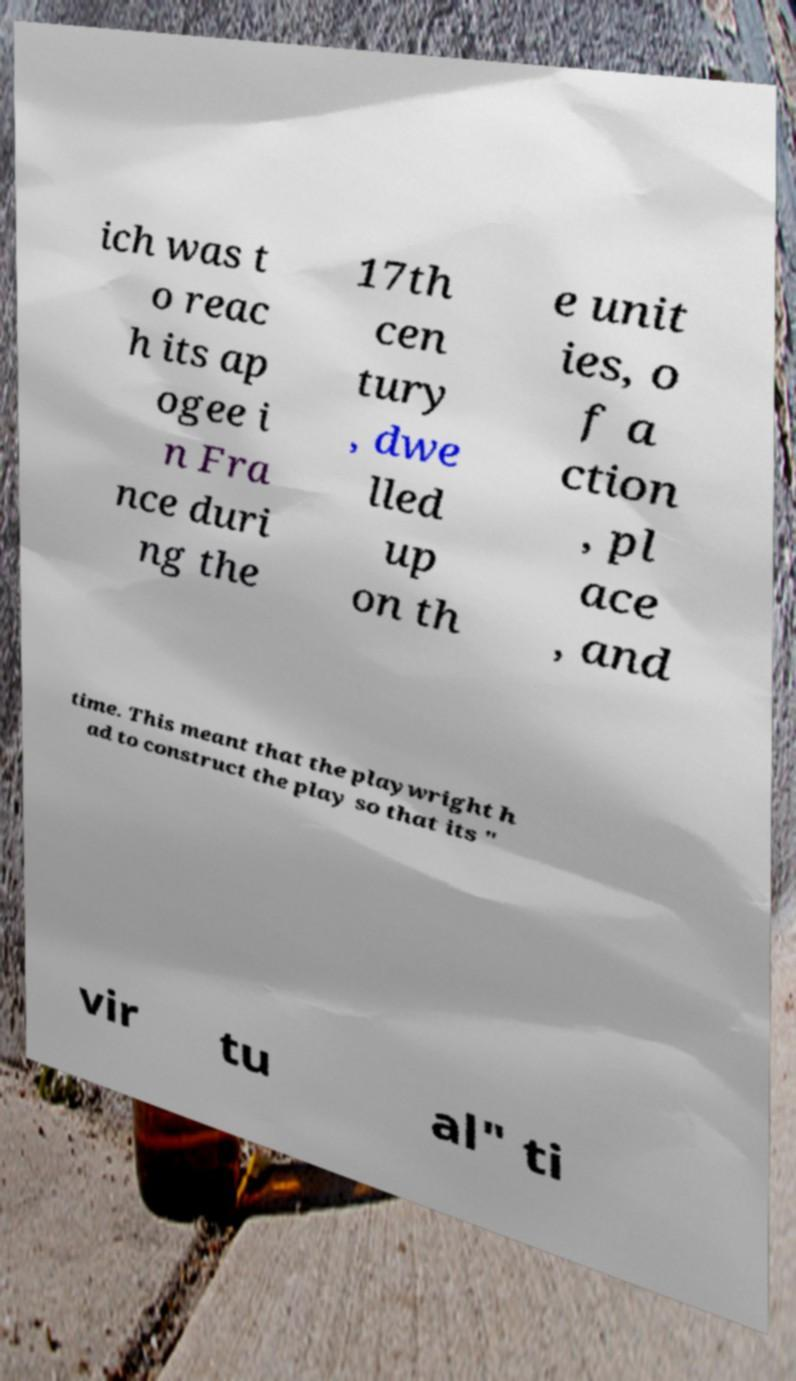Can you accurately transcribe the text from the provided image for me? ich was t o reac h its ap ogee i n Fra nce duri ng the 17th cen tury , dwe lled up on th e unit ies, o f a ction , pl ace , and time. This meant that the playwright h ad to construct the play so that its " vir tu al" ti 